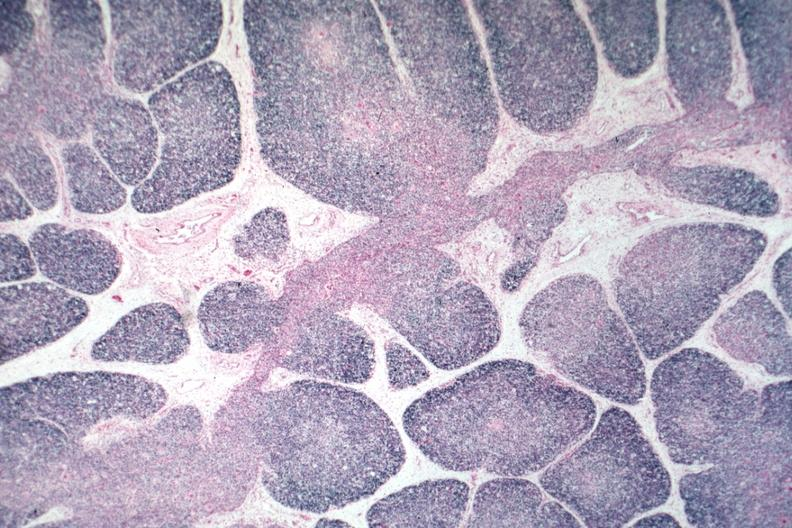what is present?
Answer the question using a single word or phrase. Hematologic 